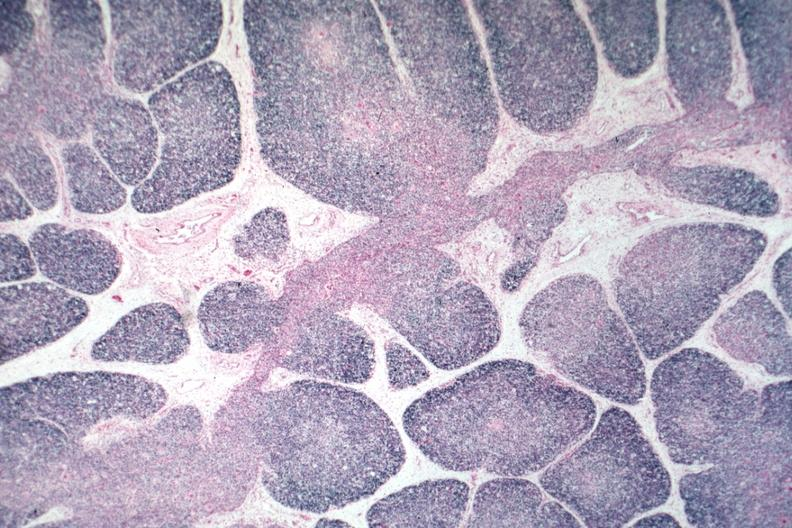what is present?
Answer the question using a single word or phrase. Hematologic 